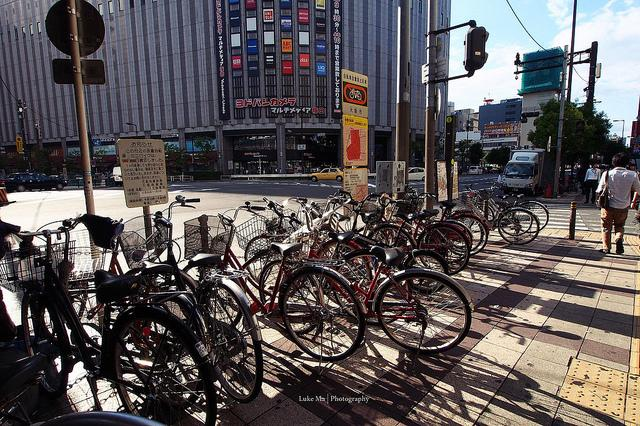Where are the owners of these bikes while this photo was taken? in building 